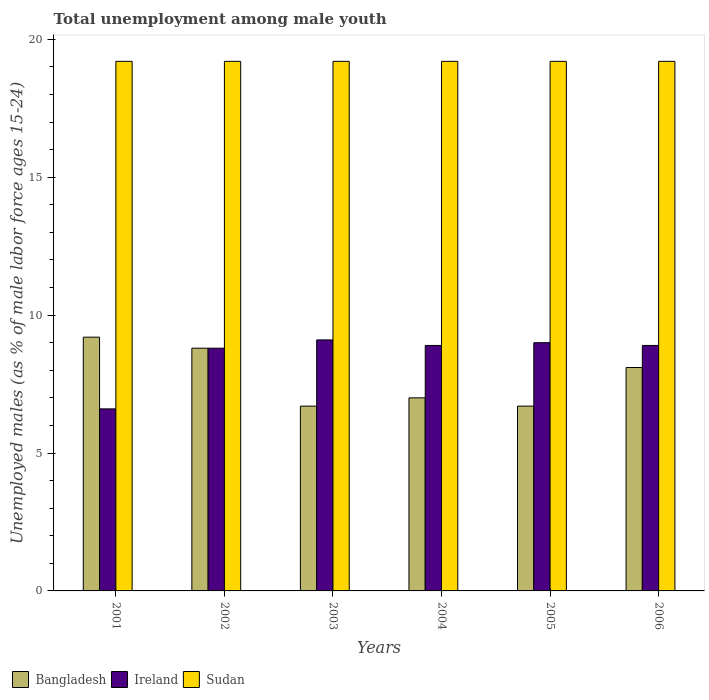Are the number of bars per tick equal to the number of legend labels?
Offer a very short reply. Yes. Are the number of bars on each tick of the X-axis equal?
Provide a short and direct response. Yes. What is the label of the 6th group of bars from the left?
Your answer should be very brief. 2006. In how many cases, is the number of bars for a given year not equal to the number of legend labels?
Your response must be concise. 0. What is the percentage of unemployed males in in Ireland in 2003?
Make the answer very short. 9.1. Across all years, what is the maximum percentage of unemployed males in in Ireland?
Keep it short and to the point. 9.1. Across all years, what is the minimum percentage of unemployed males in in Bangladesh?
Your response must be concise. 6.7. In which year was the percentage of unemployed males in in Sudan maximum?
Offer a terse response. 2001. What is the total percentage of unemployed males in in Bangladesh in the graph?
Make the answer very short. 46.5. What is the difference between the percentage of unemployed males in in Ireland in 2002 and that in 2005?
Offer a terse response. -0.2. What is the difference between the percentage of unemployed males in in Bangladesh in 2002 and the percentage of unemployed males in in Sudan in 2004?
Ensure brevity in your answer.  -10.4. What is the average percentage of unemployed males in in Bangladesh per year?
Your response must be concise. 7.75. In the year 2003, what is the difference between the percentage of unemployed males in in Ireland and percentage of unemployed males in in Sudan?
Provide a short and direct response. -10.1. Is the difference between the percentage of unemployed males in in Ireland in 2001 and 2005 greater than the difference between the percentage of unemployed males in in Sudan in 2001 and 2005?
Keep it short and to the point. No. What is the difference between the highest and the second highest percentage of unemployed males in in Bangladesh?
Ensure brevity in your answer.  0.4. What is the difference between the highest and the lowest percentage of unemployed males in in Ireland?
Provide a short and direct response. 2.5. In how many years, is the percentage of unemployed males in in Sudan greater than the average percentage of unemployed males in in Sudan taken over all years?
Your answer should be very brief. 0. What does the 1st bar from the left in 2002 represents?
Your answer should be very brief. Bangladesh. What does the 2nd bar from the right in 2002 represents?
Offer a very short reply. Ireland. Is it the case that in every year, the sum of the percentage of unemployed males in in Sudan and percentage of unemployed males in in Bangladesh is greater than the percentage of unemployed males in in Ireland?
Offer a terse response. Yes. What is the difference between two consecutive major ticks on the Y-axis?
Your answer should be very brief. 5. Does the graph contain any zero values?
Make the answer very short. No. Does the graph contain grids?
Ensure brevity in your answer.  No. How are the legend labels stacked?
Provide a short and direct response. Horizontal. What is the title of the graph?
Provide a short and direct response. Total unemployment among male youth. What is the label or title of the Y-axis?
Give a very brief answer. Unemployed males (as % of male labor force ages 15-24). What is the Unemployed males (as % of male labor force ages 15-24) of Bangladesh in 2001?
Your answer should be compact. 9.2. What is the Unemployed males (as % of male labor force ages 15-24) of Ireland in 2001?
Give a very brief answer. 6.6. What is the Unemployed males (as % of male labor force ages 15-24) of Sudan in 2001?
Your response must be concise. 19.2. What is the Unemployed males (as % of male labor force ages 15-24) of Bangladesh in 2002?
Keep it short and to the point. 8.8. What is the Unemployed males (as % of male labor force ages 15-24) in Ireland in 2002?
Make the answer very short. 8.8. What is the Unemployed males (as % of male labor force ages 15-24) of Sudan in 2002?
Make the answer very short. 19.2. What is the Unemployed males (as % of male labor force ages 15-24) of Bangladesh in 2003?
Offer a terse response. 6.7. What is the Unemployed males (as % of male labor force ages 15-24) of Ireland in 2003?
Offer a very short reply. 9.1. What is the Unemployed males (as % of male labor force ages 15-24) of Sudan in 2003?
Provide a short and direct response. 19.2. What is the Unemployed males (as % of male labor force ages 15-24) of Bangladesh in 2004?
Give a very brief answer. 7. What is the Unemployed males (as % of male labor force ages 15-24) of Ireland in 2004?
Make the answer very short. 8.9. What is the Unemployed males (as % of male labor force ages 15-24) in Sudan in 2004?
Ensure brevity in your answer.  19.2. What is the Unemployed males (as % of male labor force ages 15-24) in Bangladesh in 2005?
Keep it short and to the point. 6.7. What is the Unemployed males (as % of male labor force ages 15-24) of Ireland in 2005?
Offer a terse response. 9. What is the Unemployed males (as % of male labor force ages 15-24) of Sudan in 2005?
Your answer should be compact. 19.2. What is the Unemployed males (as % of male labor force ages 15-24) in Bangladesh in 2006?
Provide a succinct answer. 8.1. What is the Unemployed males (as % of male labor force ages 15-24) of Ireland in 2006?
Your answer should be very brief. 8.9. What is the Unemployed males (as % of male labor force ages 15-24) in Sudan in 2006?
Your response must be concise. 19.2. Across all years, what is the maximum Unemployed males (as % of male labor force ages 15-24) in Bangladesh?
Your answer should be very brief. 9.2. Across all years, what is the maximum Unemployed males (as % of male labor force ages 15-24) of Ireland?
Make the answer very short. 9.1. Across all years, what is the maximum Unemployed males (as % of male labor force ages 15-24) of Sudan?
Offer a terse response. 19.2. Across all years, what is the minimum Unemployed males (as % of male labor force ages 15-24) of Bangladesh?
Offer a terse response. 6.7. Across all years, what is the minimum Unemployed males (as % of male labor force ages 15-24) of Ireland?
Make the answer very short. 6.6. Across all years, what is the minimum Unemployed males (as % of male labor force ages 15-24) of Sudan?
Provide a short and direct response. 19.2. What is the total Unemployed males (as % of male labor force ages 15-24) of Bangladesh in the graph?
Keep it short and to the point. 46.5. What is the total Unemployed males (as % of male labor force ages 15-24) of Ireland in the graph?
Offer a terse response. 51.3. What is the total Unemployed males (as % of male labor force ages 15-24) of Sudan in the graph?
Keep it short and to the point. 115.2. What is the difference between the Unemployed males (as % of male labor force ages 15-24) of Ireland in 2001 and that in 2002?
Offer a very short reply. -2.2. What is the difference between the Unemployed males (as % of male labor force ages 15-24) in Bangladesh in 2001 and that in 2003?
Offer a very short reply. 2.5. What is the difference between the Unemployed males (as % of male labor force ages 15-24) of Ireland in 2001 and that in 2003?
Your answer should be very brief. -2.5. What is the difference between the Unemployed males (as % of male labor force ages 15-24) in Ireland in 2001 and that in 2004?
Ensure brevity in your answer.  -2.3. What is the difference between the Unemployed males (as % of male labor force ages 15-24) of Bangladesh in 2001 and that in 2005?
Provide a succinct answer. 2.5. What is the difference between the Unemployed males (as % of male labor force ages 15-24) of Sudan in 2001 and that in 2005?
Keep it short and to the point. 0. What is the difference between the Unemployed males (as % of male labor force ages 15-24) of Bangladesh in 2002 and that in 2003?
Ensure brevity in your answer.  2.1. What is the difference between the Unemployed males (as % of male labor force ages 15-24) of Ireland in 2002 and that in 2003?
Offer a very short reply. -0.3. What is the difference between the Unemployed males (as % of male labor force ages 15-24) in Sudan in 2002 and that in 2003?
Ensure brevity in your answer.  0. What is the difference between the Unemployed males (as % of male labor force ages 15-24) in Bangladesh in 2002 and that in 2005?
Your answer should be very brief. 2.1. What is the difference between the Unemployed males (as % of male labor force ages 15-24) of Ireland in 2002 and that in 2005?
Your response must be concise. -0.2. What is the difference between the Unemployed males (as % of male labor force ages 15-24) of Sudan in 2002 and that in 2006?
Provide a succinct answer. 0. What is the difference between the Unemployed males (as % of male labor force ages 15-24) of Sudan in 2003 and that in 2004?
Provide a short and direct response. 0. What is the difference between the Unemployed males (as % of male labor force ages 15-24) of Bangladesh in 2003 and that in 2005?
Make the answer very short. 0. What is the difference between the Unemployed males (as % of male labor force ages 15-24) in Sudan in 2003 and that in 2005?
Give a very brief answer. 0. What is the difference between the Unemployed males (as % of male labor force ages 15-24) in Bangladesh in 2003 and that in 2006?
Keep it short and to the point. -1.4. What is the difference between the Unemployed males (as % of male labor force ages 15-24) in Bangladesh in 2004 and that in 2005?
Offer a terse response. 0.3. What is the difference between the Unemployed males (as % of male labor force ages 15-24) in Ireland in 2004 and that in 2005?
Make the answer very short. -0.1. What is the difference between the Unemployed males (as % of male labor force ages 15-24) of Bangladesh in 2004 and that in 2006?
Your answer should be compact. -1.1. What is the difference between the Unemployed males (as % of male labor force ages 15-24) of Ireland in 2004 and that in 2006?
Offer a terse response. 0. What is the difference between the Unemployed males (as % of male labor force ages 15-24) of Ireland in 2005 and that in 2006?
Ensure brevity in your answer.  0.1. What is the difference between the Unemployed males (as % of male labor force ages 15-24) in Sudan in 2005 and that in 2006?
Offer a very short reply. 0. What is the difference between the Unemployed males (as % of male labor force ages 15-24) in Bangladesh in 2001 and the Unemployed males (as % of male labor force ages 15-24) in Ireland in 2002?
Your response must be concise. 0.4. What is the difference between the Unemployed males (as % of male labor force ages 15-24) of Ireland in 2001 and the Unemployed males (as % of male labor force ages 15-24) of Sudan in 2002?
Offer a terse response. -12.6. What is the difference between the Unemployed males (as % of male labor force ages 15-24) in Bangladesh in 2001 and the Unemployed males (as % of male labor force ages 15-24) in Ireland in 2003?
Provide a succinct answer. 0.1. What is the difference between the Unemployed males (as % of male labor force ages 15-24) in Bangladesh in 2001 and the Unemployed males (as % of male labor force ages 15-24) in Ireland in 2004?
Your response must be concise. 0.3. What is the difference between the Unemployed males (as % of male labor force ages 15-24) of Bangladesh in 2001 and the Unemployed males (as % of male labor force ages 15-24) of Sudan in 2004?
Ensure brevity in your answer.  -10. What is the difference between the Unemployed males (as % of male labor force ages 15-24) in Ireland in 2001 and the Unemployed males (as % of male labor force ages 15-24) in Sudan in 2005?
Your response must be concise. -12.6. What is the difference between the Unemployed males (as % of male labor force ages 15-24) in Bangladesh in 2001 and the Unemployed males (as % of male labor force ages 15-24) in Ireland in 2006?
Provide a short and direct response. 0.3. What is the difference between the Unemployed males (as % of male labor force ages 15-24) of Ireland in 2001 and the Unemployed males (as % of male labor force ages 15-24) of Sudan in 2006?
Make the answer very short. -12.6. What is the difference between the Unemployed males (as % of male labor force ages 15-24) in Bangladesh in 2002 and the Unemployed males (as % of male labor force ages 15-24) in Ireland in 2003?
Your response must be concise. -0.3. What is the difference between the Unemployed males (as % of male labor force ages 15-24) in Bangladesh in 2002 and the Unemployed males (as % of male labor force ages 15-24) in Sudan in 2003?
Your answer should be compact. -10.4. What is the difference between the Unemployed males (as % of male labor force ages 15-24) in Bangladesh in 2002 and the Unemployed males (as % of male labor force ages 15-24) in Ireland in 2004?
Give a very brief answer. -0.1. What is the difference between the Unemployed males (as % of male labor force ages 15-24) in Bangladesh in 2002 and the Unemployed males (as % of male labor force ages 15-24) in Ireland in 2005?
Your answer should be very brief. -0.2. What is the difference between the Unemployed males (as % of male labor force ages 15-24) of Bangladesh in 2002 and the Unemployed males (as % of male labor force ages 15-24) of Sudan in 2005?
Provide a succinct answer. -10.4. What is the difference between the Unemployed males (as % of male labor force ages 15-24) of Ireland in 2002 and the Unemployed males (as % of male labor force ages 15-24) of Sudan in 2005?
Keep it short and to the point. -10.4. What is the difference between the Unemployed males (as % of male labor force ages 15-24) of Ireland in 2002 and the Unemployed males (as % of male labor force ages 15-24) of Sudan in 2006?
Give a very brief answer. -10.4. What is the difference between the Unemployed males (as % of male labor force ages 15-24) in Bangladesh in 2003 and the Unemployed males (as % of male labor force ages 15-24) in Sudan in 2004?
Provide a succinct answer. -12.5. What is the difference between the Unemployed males (as % of male labor force ages 15-24) in Bangladesh in 2003 and the Unemployed males (as % of male labor force ages 15-24) in Ireland in 2005?
Make the answer very short. -2.3. What is the difference between the Unemployed males (as % of male labor force ages 15-24) of Ireland in 2003 and the Unemployed males (as % of male labor force ages 15-24) of Sudan in 2005?
Make the answer very short. -10.1. What is the difference between the Unemployed males (as % of male labor force ages 15-24) in Bangladesh in 2004 and the Unemployed males (as % of male labor force ages 15-24) in Sudan in 2005?
Offer a terse response. -12.2. What is the difference between the Unemployed males (as % of male labor force ages 15-24) in Ireland in 2004 and the Unemployed males (as % of male labor force ages 15-24) in Sudan in 2005?
Give a very brief answer. -10.3. What is the difference between the Unemployed males (as % of male labor force ages 15-24) in Ireland in 2004 and the Unemployed males (as % of male labor force ages 15-24) in Sudan in 2006?
Your answer should be compact. -10.3. What is the difference between the Unemployed males (as % of male labor force ages 15-24) of Bangladesh in 2005 and the Unemployed males (as % of male labor force ages 15-24) of Ireland in 2006?
Your answer should be very brief. -2.2. What is the difference between the Unemployed males (as % of male labor force ages 15-24) of Bangladesh in 2005 and the Unemployed males (as % of male labor force ages 15-24) of Sudan in 2006?
Provide a short and direct response. -12.5. What is the difference between the Unemployed males (as % of male labor force ages 15-24) of Ireland in 2005 and the Unemployed males (as % of male labor force ages 15-24) of Sudan in 2006?
Make the answer very short. -10.2. What is the average Unemployed males (as % of male labor force ages 15-24) of Bangladesh per year?
Offer a terse response. 7.75. What is the average Unemployed males (as % of male labor force ages 15-24) of Ireland per year?
Provide a short and direct response. 8.55. What is the average Unemployed males (as % of male labor force ages 15-24) of Sudan per year?
Make the answer very short. 19.2. In the year 2002, what is the difference between the Unemployed males (as % of male labor force ages 15-24) of Ireland and Unemployed males (as % of male labor force ages 15-24) of Sudan?
Make the answer very short. -10.4. In the year 2003, what is the difference between the Unemployed males (as % of male labor force ages 15-24) in Bangladesh and Unemployed males (as % of male labor force ages 15-24) in Sudan?
Provide a short and direct response. -12.5. In the year 2004, what is the difference between the Unemployed males (as % of male labor force ages 15-24) of Bangladesh and Unemployed males (as % of male labor force ages 15-24) of Ireland?
Provide a succinct answer. -1.9. In the year 2004, what is the difference between the Unemployed males (as % of male labor force ages 15-24) of Bangladesh and Unemployed males (as % of male labor force ages 15-24) of Sudan?
Give a very brief answer. -12.2. In the year 2006, what is the difference between the Unemployed males (as % of male labor force ages 15-24) in Bangladesh and Unemployed males (as % of male labor force ages 15-24) in Ireland?
Give a very brief answer. -0.8. What is the ratio of the Unemployed males (as % of male labor force ages 15-24) in Bangladesh in 2001 to that in 2002?
Your answer should be very brief. 1.05. What is the ratio of the Unemployed males (as % of male labor force ages 15-24) in Sudan in 2001 to that in 2002?
Provide a short and direct response. 1. What is the ratio of the Unemployed males (as % of male labor force ages 15-24) in Bangladesh in 2001 to that in 2003?
Provide a short and direct response. 1.37. What is the ratio of the Unemployed males (as % of male labor force ages 15-24) in Ireland in 2001 to that in 2003?
Offer a terse response. 0.73. What is the ratio of the Unemployed males (as % of male labor force ages 15-24) in Sudan in 2001 to that in 2003?
Offer a terse response. 1. What is the ratio of the Unemployed males (as % of male labor force ages 15-24) in Bangladesh in 2001 to that in 2004?
Offer a terse response. 1.31. What is the ratio of the Unemployed males (as % of male labor force ages 15-24) of Ireland in 2001 to that in 2004?
Make the answer very short. 0.74. What is the ratio of the Unemployed males (as % of male labor force ages 15-24) of Sudan in 2001 to that in 2004?
Your answer should be very brief. 1. What is the ratio of the Unemployed males (as % of male labor force ages 15-24) of Bangladesh in 2001 to that in 2005?
Provide a short and direct response. 1.37. What is the ratio of the Unemployed males (as % of male labor force ages 15-24) of Ireland in 2001 to that in 2005?
Give a very brief answer. 0.73. What is the ratio of the Unemployed males (as % of male labor force ages 15-24) in Bangladesh in 2001 to that in 2006?
Your response must be concise. 1.14. What is the ratio of the Unemployed males (as % of male labor force ages 15-24) in Ireland in 2001 to that in 2006?
Offer a terse response. 0.74. What is the ratio of the Unemployed males (as % of male labor force ages 15-24) of Bangladesh in 2002 to that in 2003?
Offer a very short reply. 1.31. What is the ratio of the Unemployed males (as % of male labor force ages 15-24) in Bangladesh in 2002 to that in 2004?
Your answer should be compact. 1.26. What is the ratio of the Unemployed males (as % of male labor force ages 15-24) in Ireland in 2002 to that in 2004?
Your response must be concise. 0.99. What is the ratio of the Unemployed males (as % of male labor force ages 15-24) in Bangladesh in 2002 to that in 2005?
Your answer should be very brief. 1.31. What is the ratio of the Unemployed males (as % of male labor force ages 15-24) in Ireland in 2002 to that in 2005?
Provide a short and direct response. 0.98. What is the ratio of the Unemployed males (as % of male labor force ages 15-24) of Sudan in 2002 to that in 2005?
Provide a short and direct response. 1. What is the ratio of the Unemployed males (as % of male labor force ages 15-24) in Bangladesh in 2002 to that in 2006?
Your answer should be compact. 1.09. What is the ratio of the Unemployed males (as % of male labor force ages 15-24) of Sudan in 2002 to that in 2006?
Offer a very short reply. 1. What is the ratio of the Unemployed males (as % of male labor force ages 15-24) of Bangladesh in 2003 to that in 2004?
Keep it short and to the point. 0.96. What is the ratio of the Unemployed males (as % of male labor force ages 15-24) of Ireland in 2003 to that in 2004?
Ensure brevity in your answer.  1.02. What is the ratio of the Unemployed males (as % of male labor force ages 15-24) in Sudan in 2003 to that in 2004?
Offer a terse response. 1. What is the ratio of the Unemployed males (as % of male labor force ages 15-24) in Ireland in 2003 to that in 2005?
Provide a succinct answer. 1.01. What is the ratio of the Unemployed males (as % of male labor force ages 15-24) in Sudan in 2003 to that in 2005?
Provide a succinct answer. 1. What is the ratio of the Unemployed males (as % of male labor force ages 15-24) in Bangladesh in 2003 to that in 2006?
Offer a terse response. 0.83. What is the ratio of the Unemployed males (as % of male labor force ages 15-24) in Ireland in 2003 to that in 2006?
Your answer should be compact. 1.02. What is the ratio of the Unemployed males (as % of male labor force ages 15-24) in Sudan in 2003 to that in 2006?
Offer a terse response. 1. What is the ratio of the Unemployed males (as % of male labor force ages 15-24) of Bangladesh in 2004 to that in 2005?
Ensure brevity in your answer.  1.04. What is the ratio of the Unemployed males (as % of male labor force ages 15-24) in Ireland in 2004 to that in 2005?
Your answer should be very brief. 0.99. What is the ratio of the Unemployed males (as % of male labor force ages 15-24) of Bangladesh in 2004 to that in 2006?
Ensure brevity in your answer.  0.86. What is the ratio of the Unemployed males (as % of male labor force ages 15-24) of Ireland in 2004 to that in 2006?
Provide a succinct answer. 1. What is the ratio of the Unemployed males (as % of male labor force ages 15-24) of Bangladesh in 2005 to that in 2006?
Ensure brevity in your answer.  0.83. What is the ratio of the Unemployed males (as % of male labor force ages 15-24) in Ireland in 2005 to that in 2006?
Provide a succinct answer. 1.01. What is the difference between the highest and the second highest Unemployed males (as % of male labor force ages 15-24) in Ireland?
Your response must be concise. 0.1. What is the difference between the highest and the lowest Unemployed males (as % of male labor force ages 15-24) in Bangladesh?
Keep it short and to the point. 2.5. 